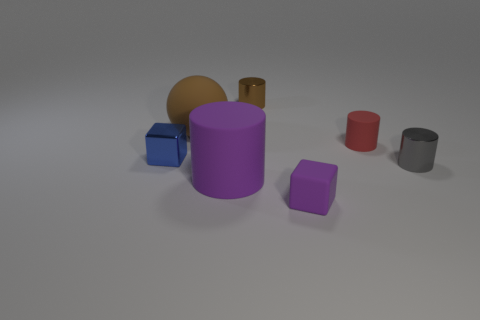Subtract all tiny red matte cylinders. How many cylinders are left? 3 Subtract all gray cylinders. How many cylinders are left? 3 Add 2 tiny purple matte cubes. How many objects exist? 9 Subtract all blue cylinders. Subtract all cyan cubes. How many cylinders are left? 4 Subtract all cylinders. How many objects are left? 3 Add 5 purple matte blocks. How many purple matte blocks exist? 6 Subtract 1 purple cubes. How many objects are left? 6 Subtract all balls. Subtract all blue shiny cubes. How many objects are left? 5 Add 7 brown metal things. How many brown metal things are left? 8 